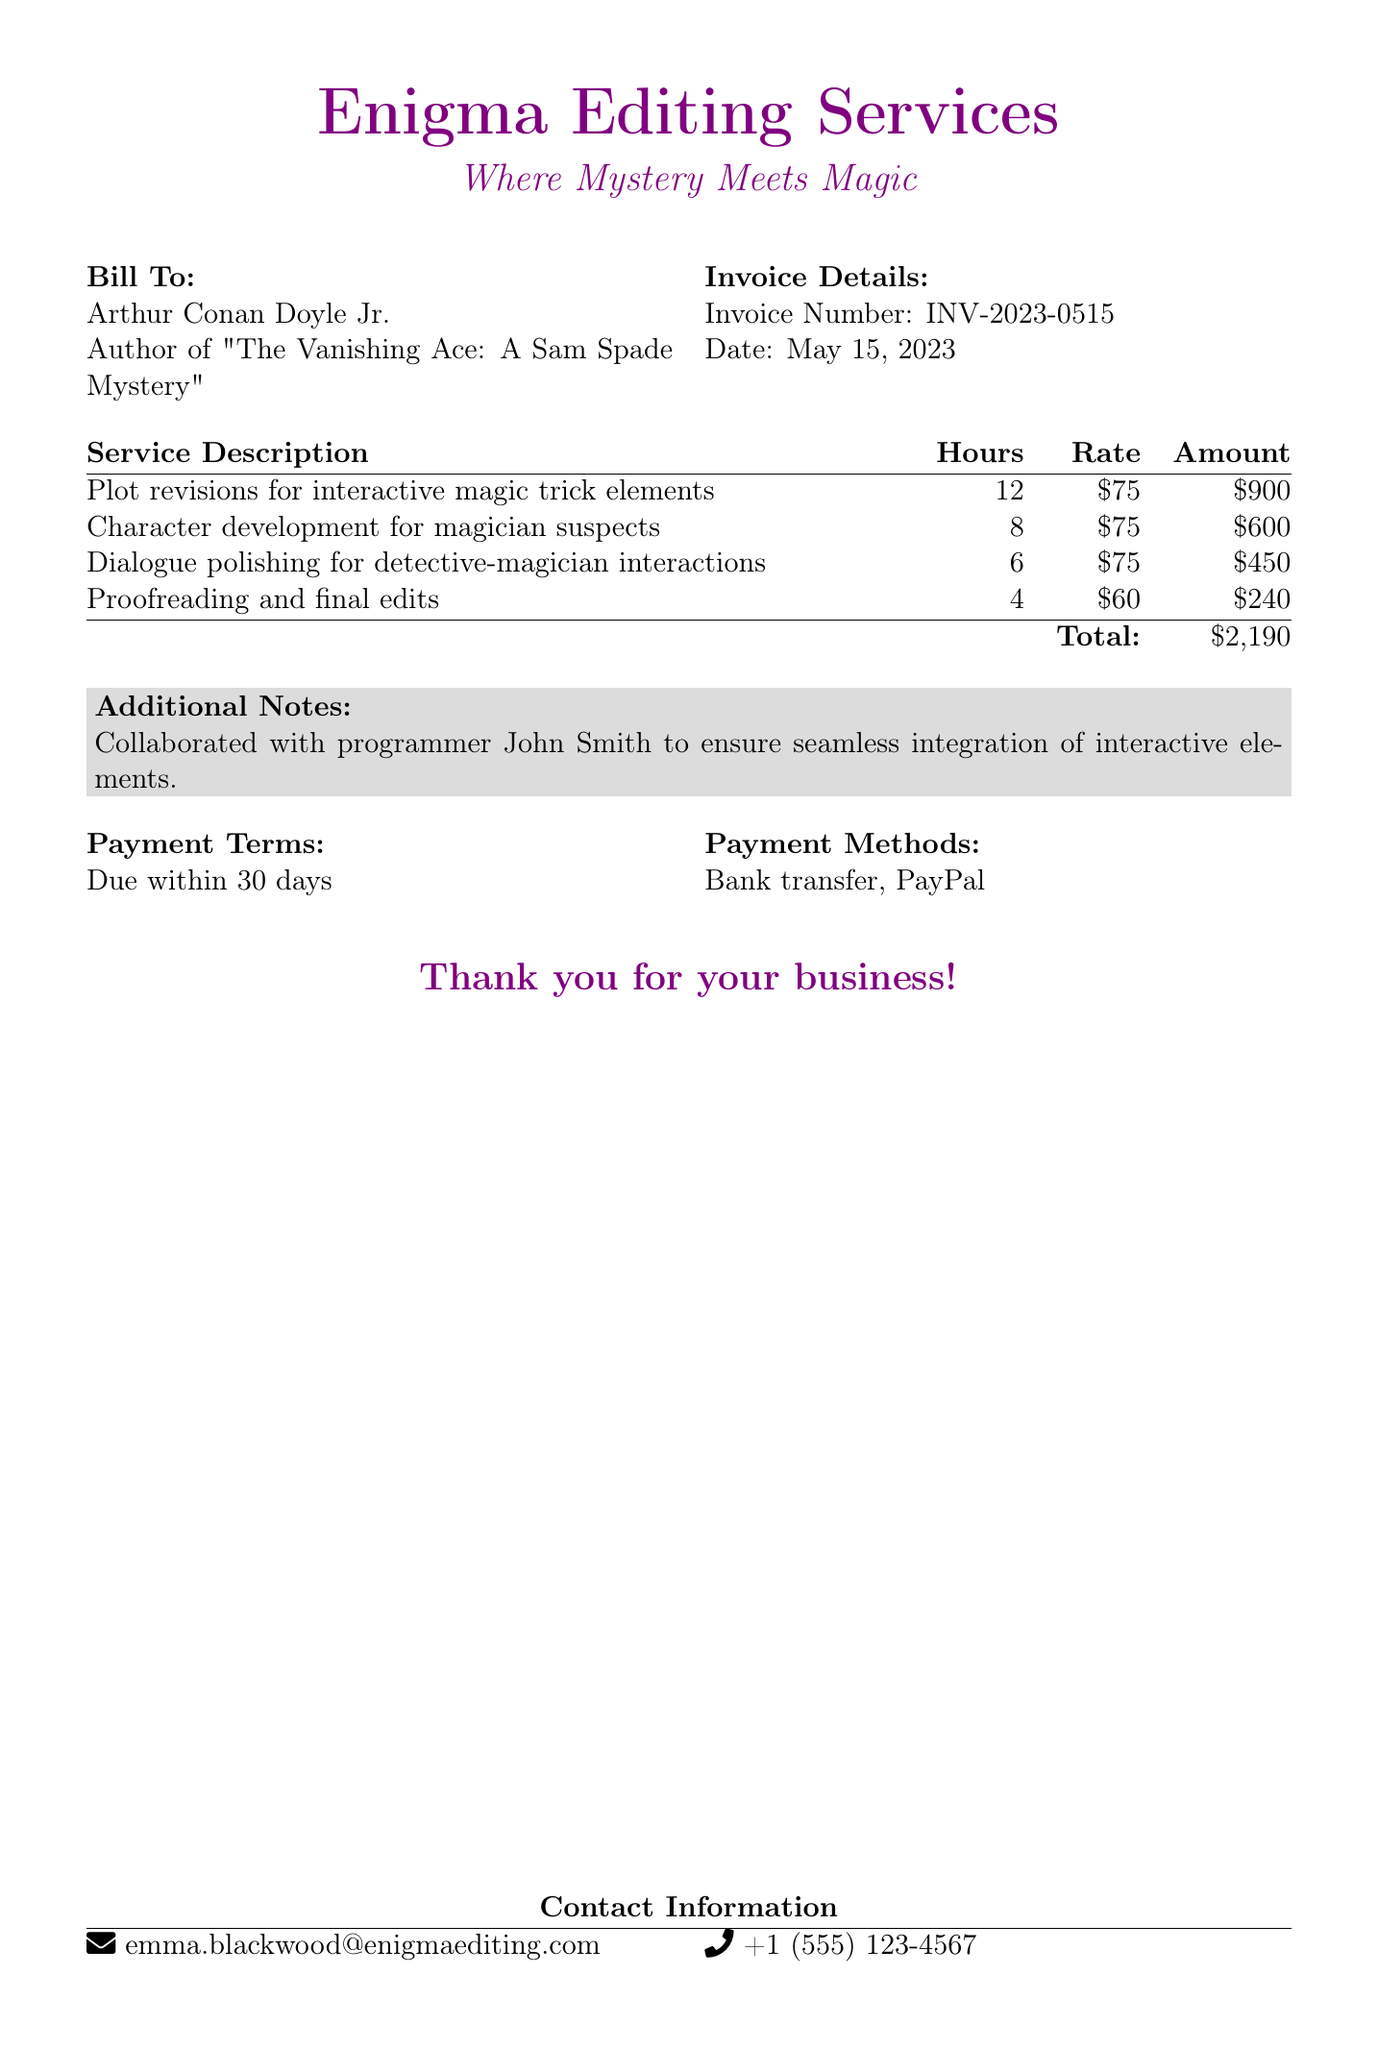What is the invoice number? The invoice number is listed in the invoice details section, which is INV-2023-0515.
Answer: INV-2023-0515 Who is the bill recipient? The bill recipient, or the client, is identified at the top of the document as Arthur Conan Doyle Jr.
Answer: Arthur Conan Doyle Jr How many hours were spent on plot revisions? The document outlines that 12 hours were dedicated to plot revisions for interactive magic trick elements.
Answer: 12 What is the total amount due? The total amount due is provided at the end of the billing section, calculated as the sum of all individual service amounts.
Answer: $2,190 What is the rate for proofreading and final edits? The rate for proofreading and final edits is specified in the service description table as $60 per hour.
Answer: $60 How many hours were allocated for character development? The document specifies that 8 hours were set aside for character development for magician suspects.
Answer: 8 What is the payment term stated in the document? The payment term is mentioned under the payment terms section, which indicates due within 30 days.
Answer: Due within 30 days Who collaborated with the editing service for interactive elements? The additional notes section highlights the collaboration with a programmer for the project, specifically naming John Smith.
Answer: John Smith 